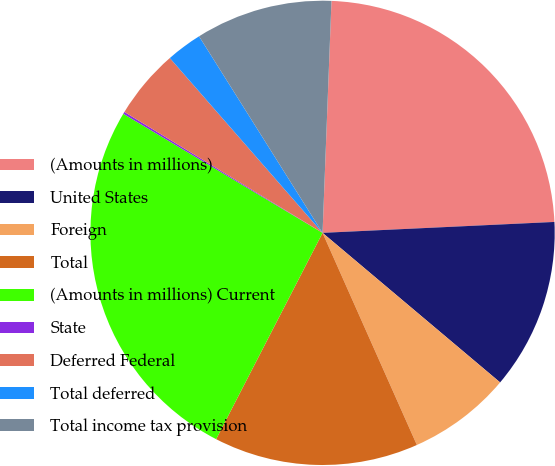Convert chart. <chart><loc_0><loc_0><loc_500><loc_500><pie_chart><fcel>(Amounts in millions)<fcel>United States<fcel>Foreign<fcel>Total<fcel>(Amounts in millions) Current<fcel>State<fcel>Deferred Federal<fcel>Total deferred<fcel>Total income tax provision<nl><fcel>23.64%<fcel>11.89%<fcel>7.2%<fcel>14.24%<fcel>25.99%<fcel>0.15%<fcel>4.85%<fcel>2.5%<fcel>9.54%<nl></chart> 